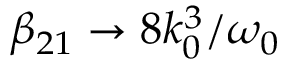Convert formula to latex. <formula><loc_0><loc_0><loc_500><loc_500>\beta _ { 2 1 } \to 8 k _ { 0 } ^ { 3 } / \omega _ { 0 }</formula> 